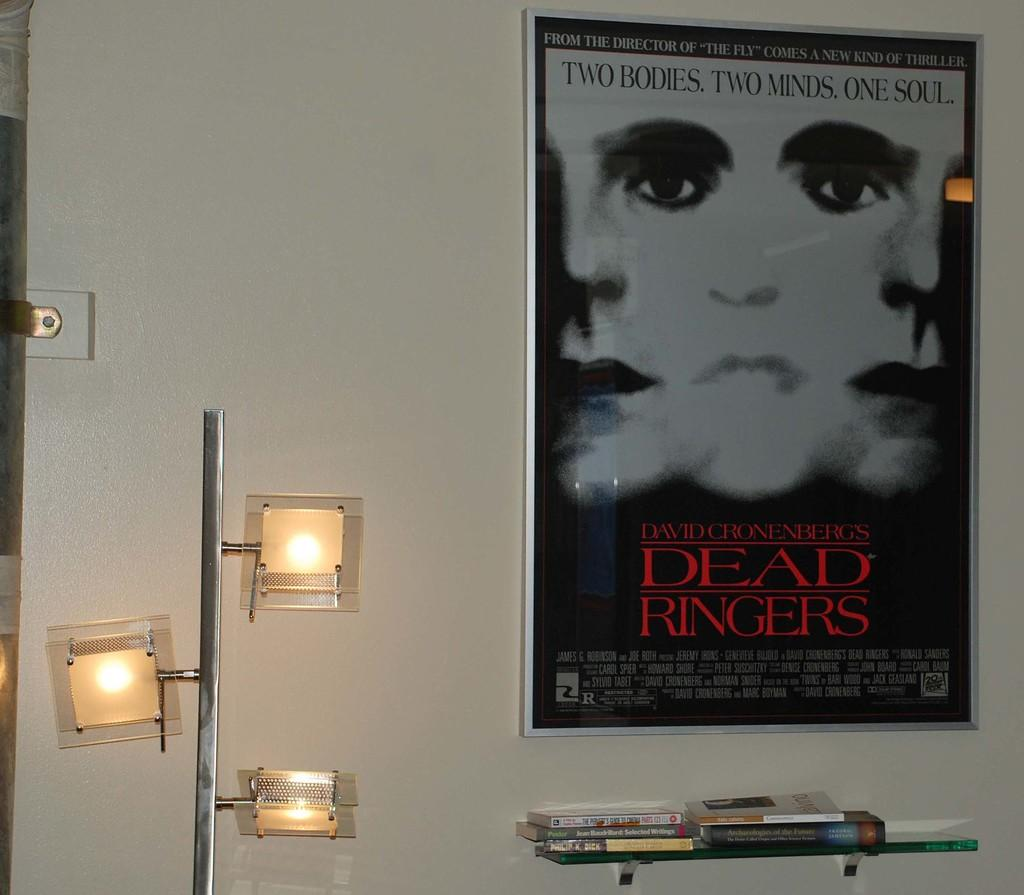Provide a one-sentence caption for the provided image. a room with a Dead Ringers poster on the wall. 